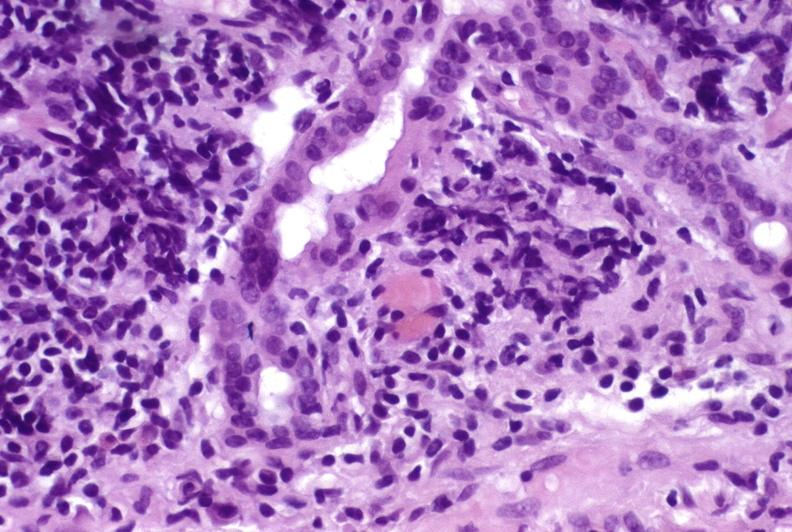what is present?
Answer the question using a single word or phrase. Liver 